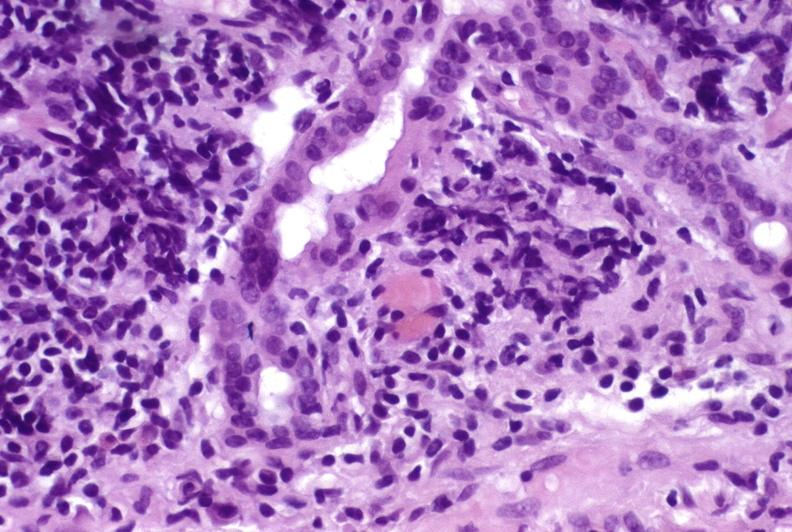what is present?
Answer the question using a single word or phrase. Liver 